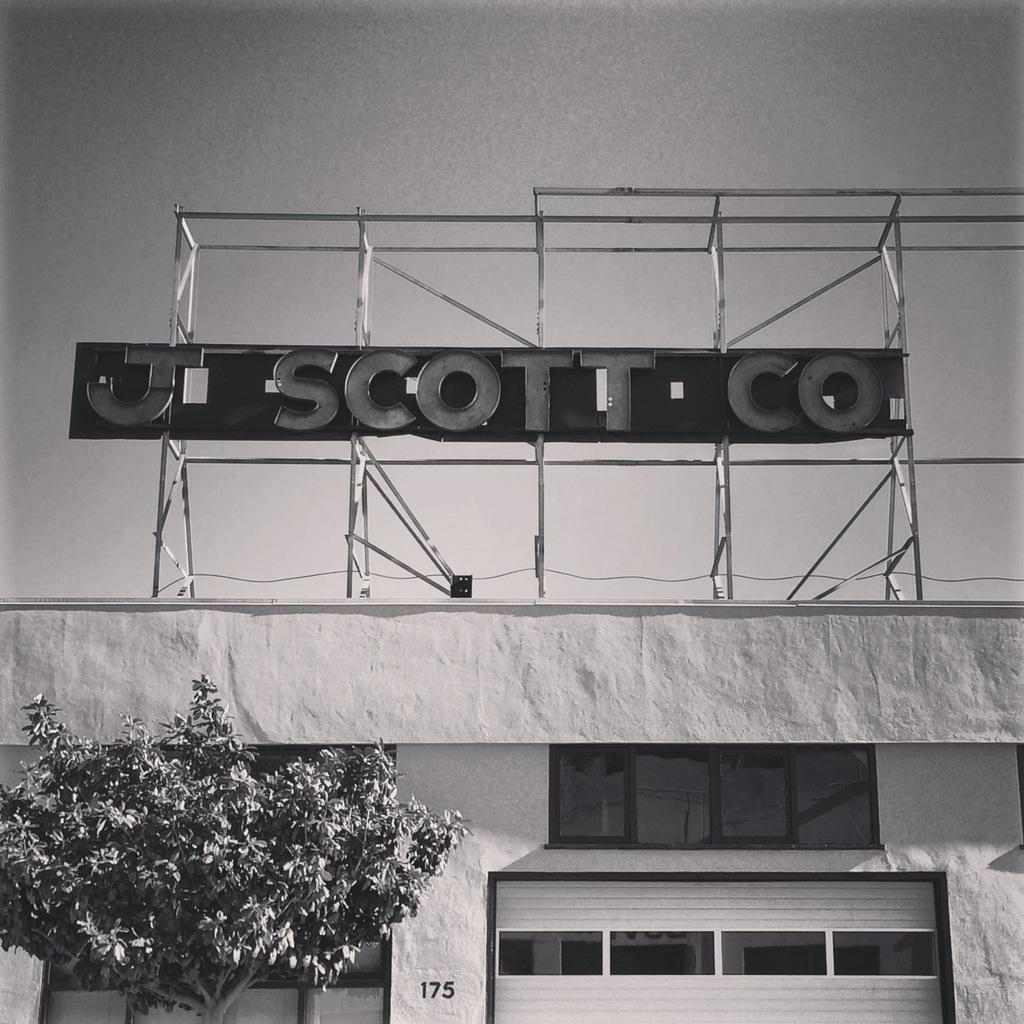Provide a one-sentence caption for the provided image. A sign board for teh J Scott Co above a building with a garage door. 